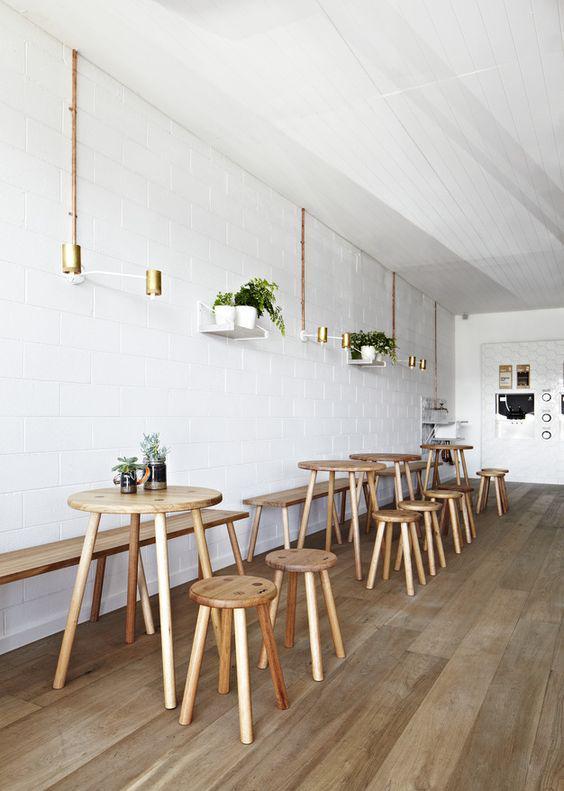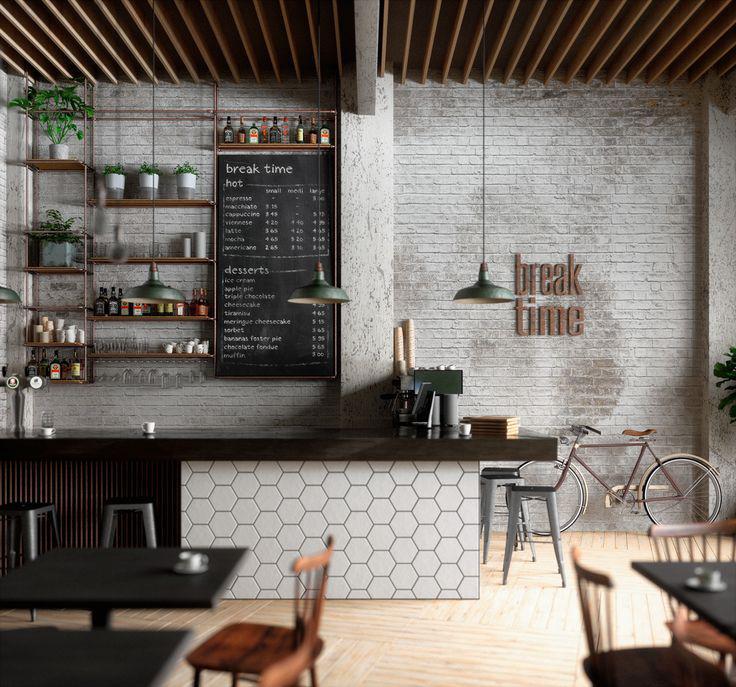The first image is the image on the left, the second image is the image on the right. Analyze the images presented: Is the assertion "Each image shows a cafe with seating on white chairs near an interior brick wall, but potted plants are in only one image." valid? Answer yes or no. No. The first image is the image on the left, the second image is the image on the right. Given the left and right images, does the statement "Some of the white chairs are made of metal." hold true? Answer yes or no. No. 